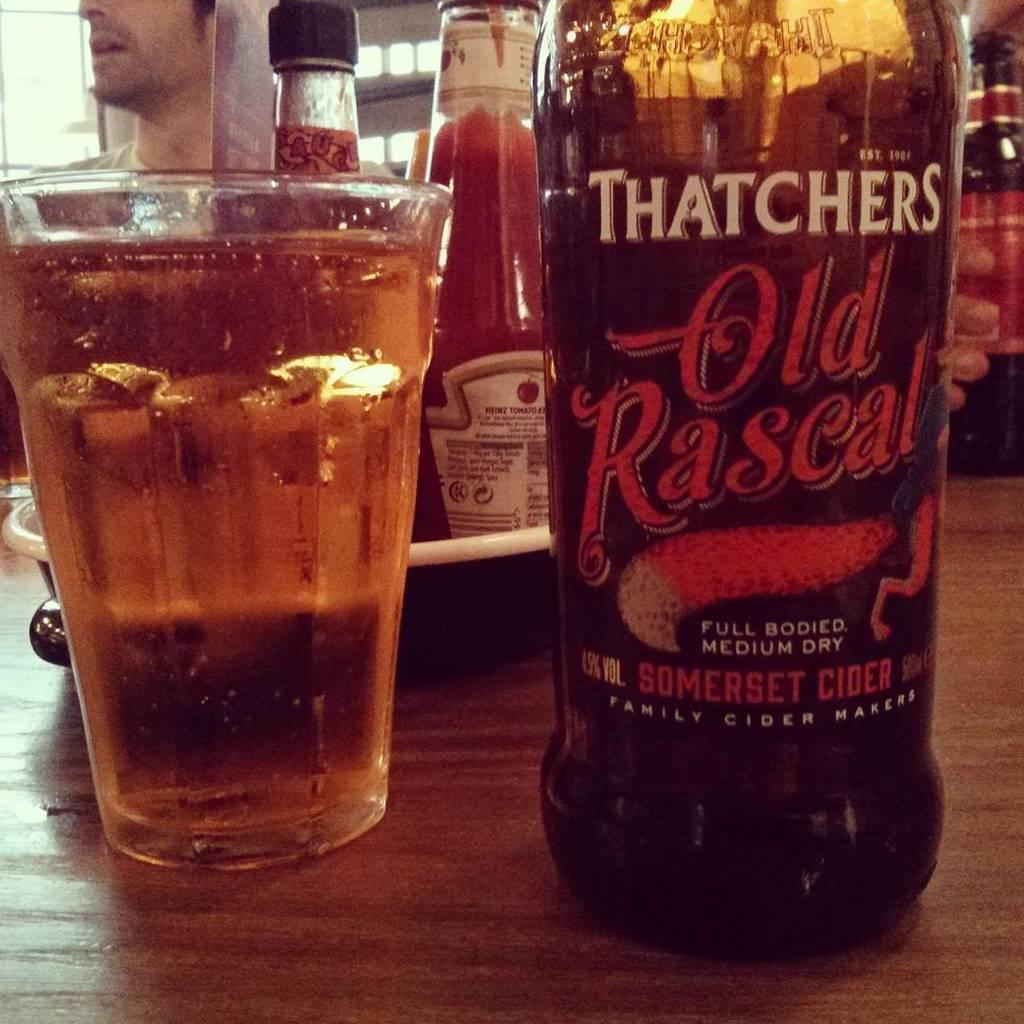<image>
Render a clear and concise summary of the photo. Bottle of Old Rascal next to a cup of beer. 